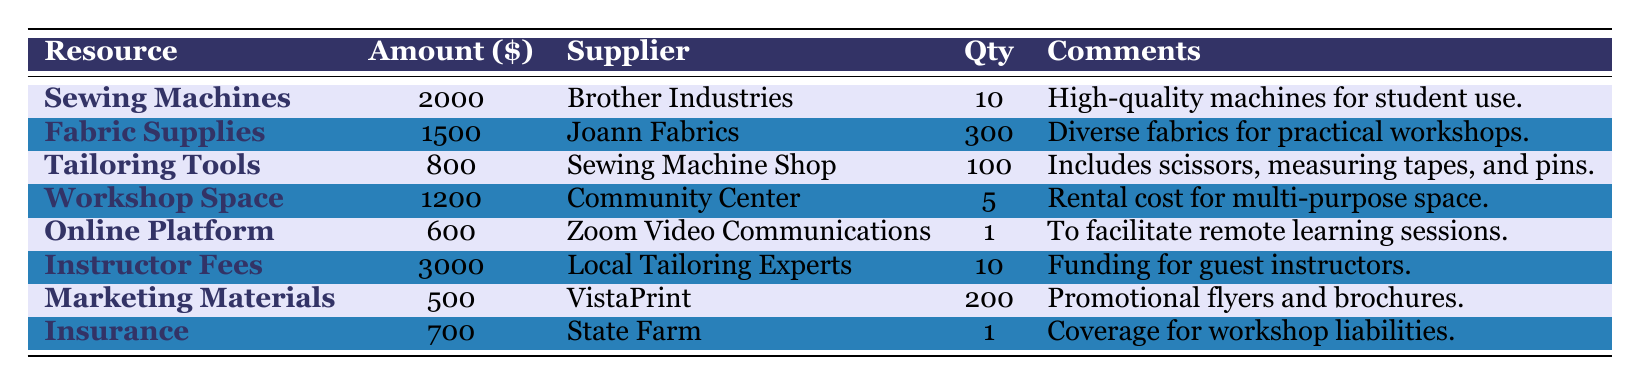What is the allocated amount for Sewing Machines? The table lists the allocated amount for Sewing Machines as $2000 under the "Amount" column.
Answer: 2000 Which supplier provides the Tailoring Tools? The table states that the supplier for Tailoring Tools is "Sewing Machine Shop."
Answer: Sewing Machine Shop How many units of Fabric Supplies are allocated? The "Qty" column for Fabric Supplies indicates that 300 units are allocated.
Answer: 300 What is the total allocated amount for Workshop Space and Online Platform Subscription? To find the total, add the allocated amounts for Workshop Space ($1200) and Online Platform Subscription ($600): 1200 + 600 = 1800.
Answer: 1800 Are there more funds allocated for Instructor Fees than for Fabric Supplies? Instructor Fees are allocated $3000, and Fabric Supplies are allocated $1500. Since $3000 is greater than $1500, the answer is yes.
Answer: Yes What is the total budget allocated for all resources listed in the table? First, sum all the allocated amounts: Sewing Machines ($2000) + Fabric Supplies ($1500) + Tailoring Tools ($800) + Workshop Space ($1200) + Online Platform Subscription ($600) + Instructor Fees ($3000) + Marketing Materials ($500) + Insurance ($700) = $10500.
Answer: 10500 Which resource has the highest quantity and how many units are allocated? The resource with the highest quantity is Fabric Supplies, with 300 units allocated, which can be found in the "Qty" column.
Answer: 300 What is the difference between the allocated amounts for Instructor Fees and Marketing Materials? To find the difference, subtract the allocated amount for Marketing Materials ($500) from Instructor Fees ($3000): 3000 - 500 = 2500.
Answer: 2500 Is insurance coverage included for the workshop liabilities? The comments for the Insurance resource state that it provides coverage for workshop liabilities, confirming that insurance coverage is included.
Answer: Yes How many total suppliers are involved in this budget allocation? The number of unique suppliers can be counted by analyzing the "Supplier" column. There are 7 unique suppliers listed.
Answer: 7 